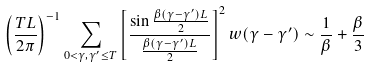Convert formula to latex. <formula><loc_0><loc_0><loc_500><loc_500>\left ( \frac { T L } { 2 \pi } \right ) ^ { - 1 } \sum _ { 0 < \gamma , \gamma ^ { \prime } \leq T } \left [ \frac { \sin { \frac { \beta ( \gamma - \gamma ^ { \prime } ) L } { 2 } } } { \frac { \beta ( \gamma - \gamma ^ { \prime } ) L } { 2 } } \right ] ^ { 2 } w ( \gamma - \gamma ^ { \prime } ) \sim \frac { 1 } { \beta } + \frac { \beta } { 3 }</formula> 